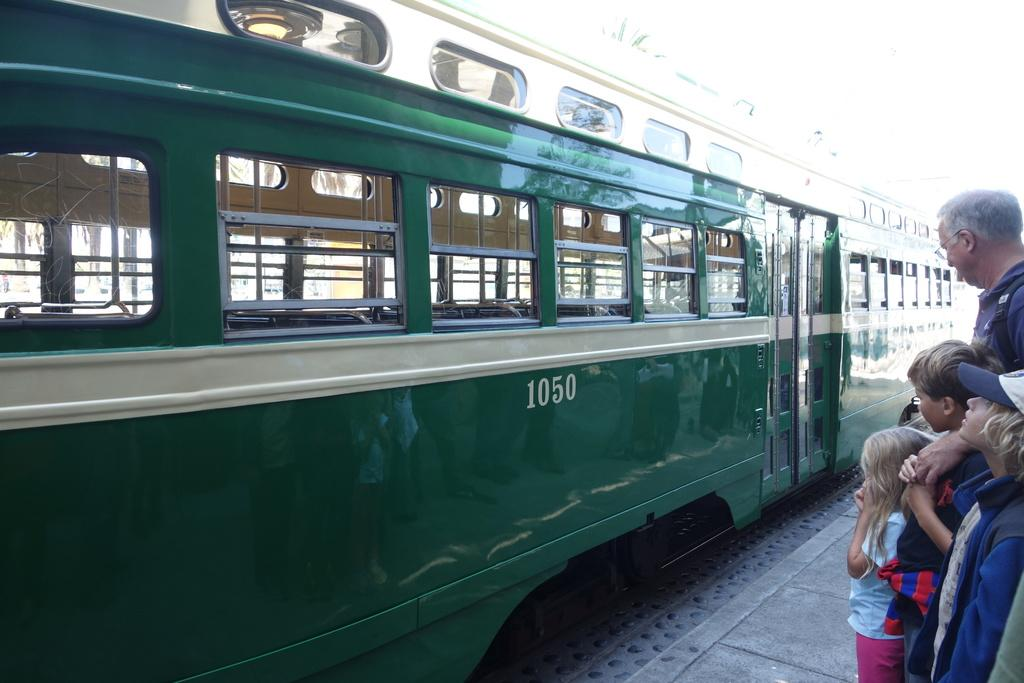How many kids are in the image? There are three kids in the image. Is there anyone else besides the kids in the image? Yes, there is an adult in the image. Where are the kids and the adult standing? They are standing on a platform. What is in front of them? A train is in front of them. What type of boats can be seen in the image? There are no boats present in the image. Is there any yarn being used by the kids or the adult in the image? There is no yarn visible in the image. 